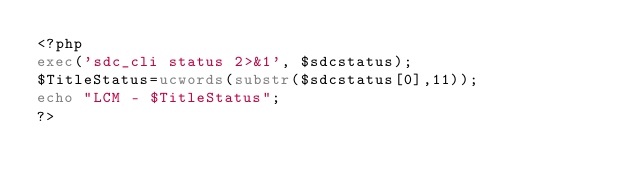<code> <loc_0><loc_0><loc_500><loc_500><_PHP_><?php
exec('sdc_cli status 2>&1', $sdcstatus);
$TitleStatus=ucwords(substr($sdcstatus[0],11));
echo "LCM - $TitleStatus";
?>
</code> 